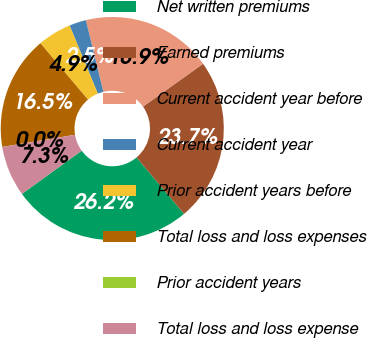Convert chart to OTSL. <chart><loc_0><loc_0><loc_500><loc_500><pie_chart><fcel>Net written premiums<fcel>Earned premiums<fcel>Current accident year before<fcel>Current accident year<fcel>Prior accident years before<fcel>Total loss and loss expenses<fcel>Prior accident years<fcel>Total loss and loss expense<nl><fcel>26.16%<fcel>23.73%<fcel>18.94%<fcel>2.45%<fcel>4.89%<fcel>16.5%<fcel>0.01%<fcel>7.32%<nl></chart> 